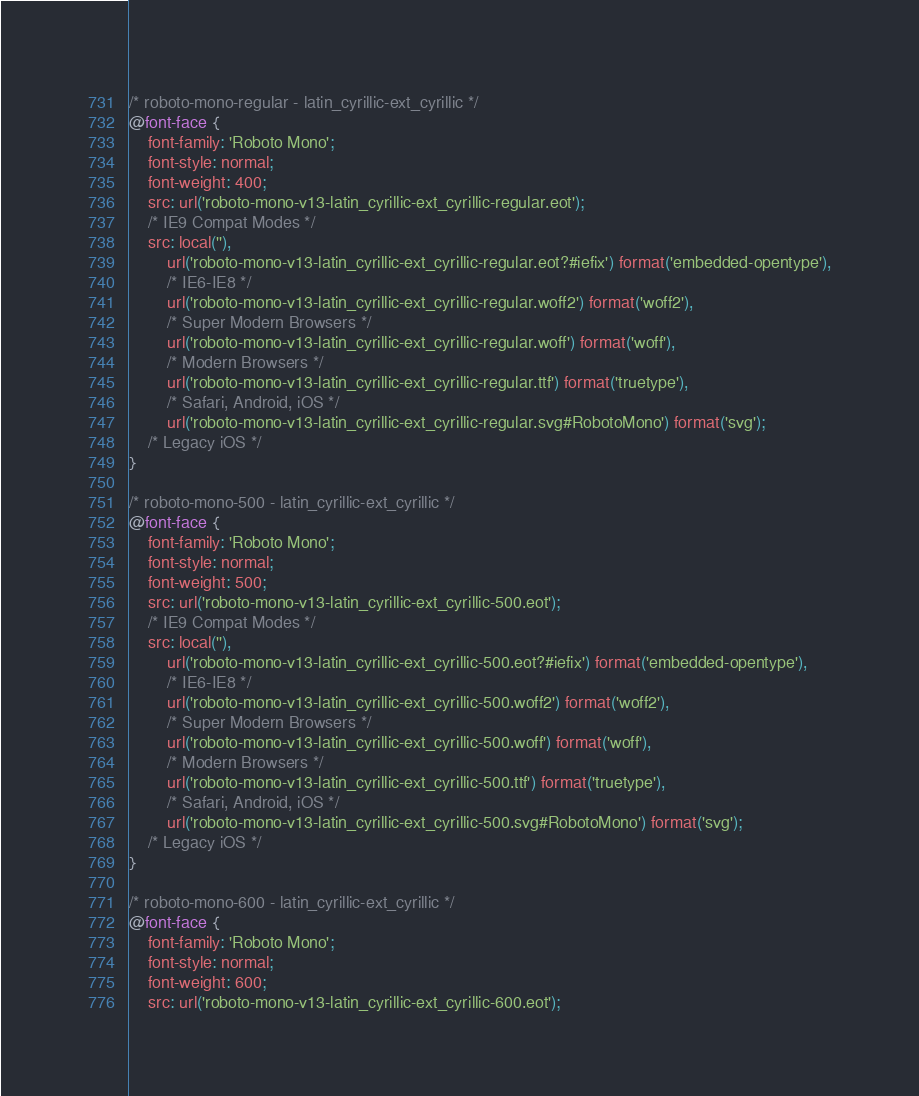Convert code to text. <code><loc_0><loc_0><loc_500><loc_500><_CSS_>/* roboto-mono-regular - latin_cyrillic-ext_cyrillic */
@font-face {
    font-family: 'Roboto Mono';
    font-style: normal;
    font-weight: 400;
    src: url('roboto-mono-v13-latin_cyrillic-ext_cyrillic-regular.eot');
    /* IE9 Compat Modes */
    src: local(''),
        url('roboto-mono-v13-latin_cyrillic-ext_cyrillic-regular.eot?#iefix') format('embedded-opentype'),
        /* IE6-IE8 */
        url('roboto-mono-v13-latin_cyrillic-ext_cyrillic-regular.woff2') format('woff2'),
        /* Super Modern Browsers */
        url('roboto-mono-v13-latin_cyrillic-ext_cyrillic-regular.woff') format('woff'),
        /* Modern Browsers */
        url('roboto-mono-v13-latin_cyrillic-ext_cyrillic-regular.ttf') format('truetype'),
        /* Safari, Android, iOS */
        url('roboto-mono-v13-latin_cyrillic-ext_cyrillic-regular.svg#RobotoMono') format('svg');
    /* Legacy iOS */
}

/* roboto-mono-500 - latin_cyrillic-ext_cyrillic */
@font-face {
    font-family: 'Roboto Mono';
    font-style: normal;
    font-weight: 500;
    src: url('roboto-mono-v13-latin_cyrillic-ext_cyrillic-500.eot');
    /* IE9 Compat Modes */
    src: local(''),
        url('roboto-mono-v13-latin_cyrillic-ext_cyrillic-500.eot?#iefix') format('embedded-opentype'),
        /* IE6-IE8 */
        url('roboto-mono-v13-latin_cyrillic-ext_cyrillic-500.woff2') format('woff2'),
        /* Super Modern Browsers */
        url('roboto-mono-v13-latin_cyrillic-ext_cyrillic-500.woff') format('woff'),
        /* Modern Browsers */
        url('roboto-mono-v13-latin_cyrillic-ext_cyrillic-500.ttf') format('truetype'),
        /* Safari, Android, iOS */
        url('roboto-mono-v13-latin_cyrillic-ext_cyrillic-500.svg#RobotoMono') format('svg');
    /* Legacy iOS */
}

/* roboto-mono-600 - latin_cyrillic-ext_cyrillic */
@font-face {
    font-family: 'Roboto Mono';
    font-style: normal;
    font-weight: 600;
    src: url('roboto-mono-v13-latin_cyrillic-ext_cyrillic-600.eot');</code> 